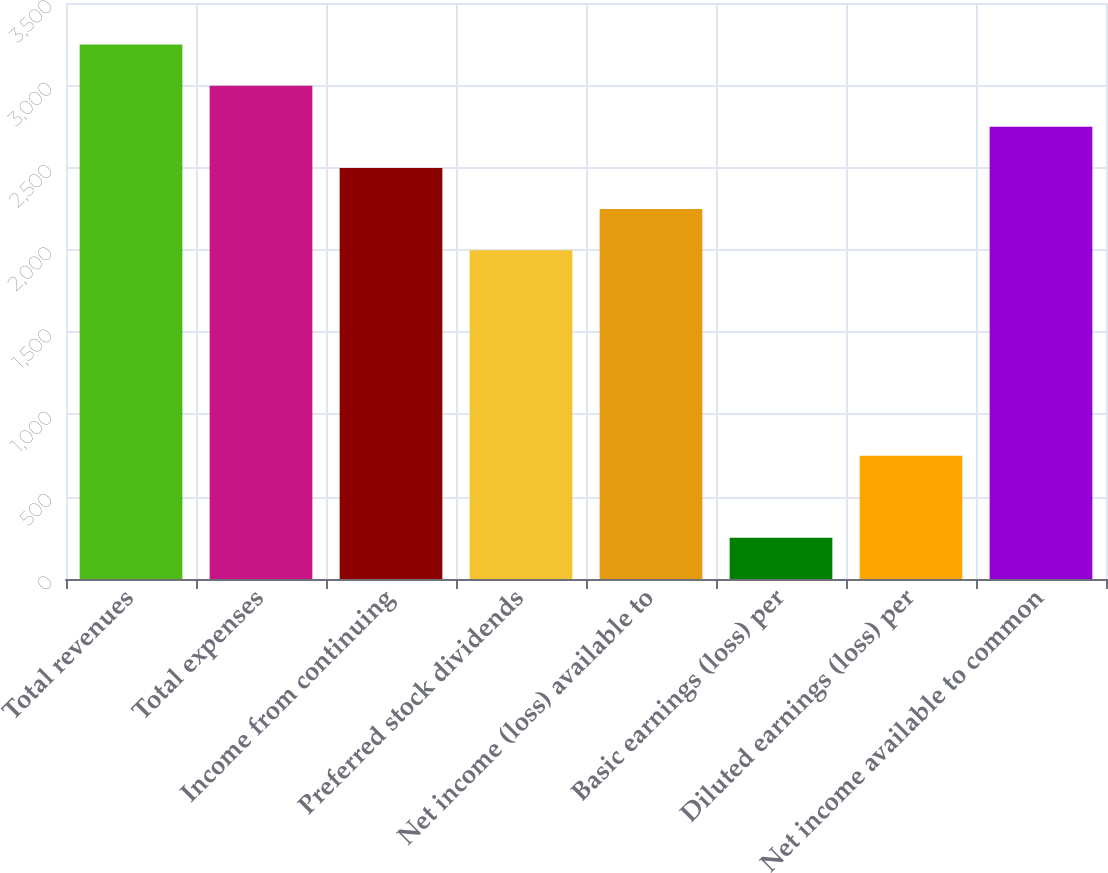Convert chart. <chart><loc_0><loc_0><loc_500><loc_500><bar_chart><fcel>Total revenues<fcel>Total expenses<fcel>Income from continuing<fcel>Preferred stock dividends<fcel>Net income (loss) available to<fcel>Basic earnings (loss) per<fcel>Diluted earnings (loss) per<fcel>Net income available to common<nl><fcel>3247.09<fcel>2997.34<fcel>2497.84<fcel>1998.35<fcel>2248.09<fcel>250.1<fcel>749.6<fcel>2747.59<nl></chart> 